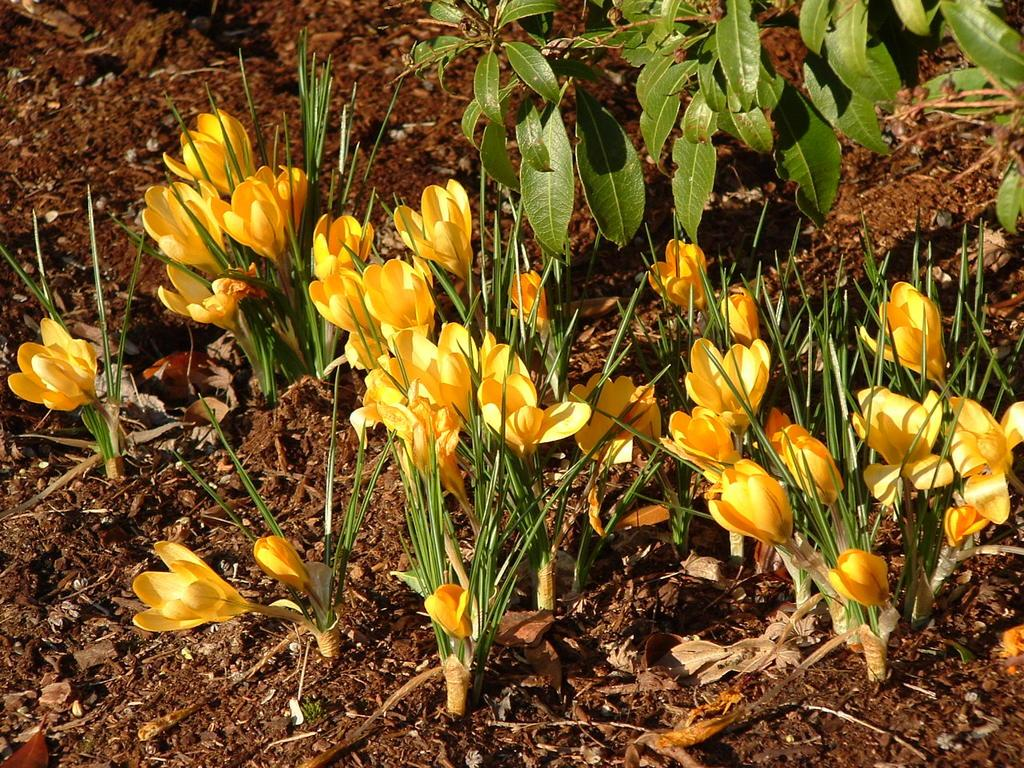What type of plants can be seen in the image? There are flower plants in the image. What part of the plants is visible in the image? Plant leaves and stems are present at the top of the image. What is visible beneath the plants in the image? The ground is visible in the image. How many pigs can be seen playing with the leaves in the image? There are no pigs present in the image; it features flower plants and their leaves. What type of things are being used to create the image? The image is a photograph or illustration, and the medium used to create it is not visible in the image itself. 